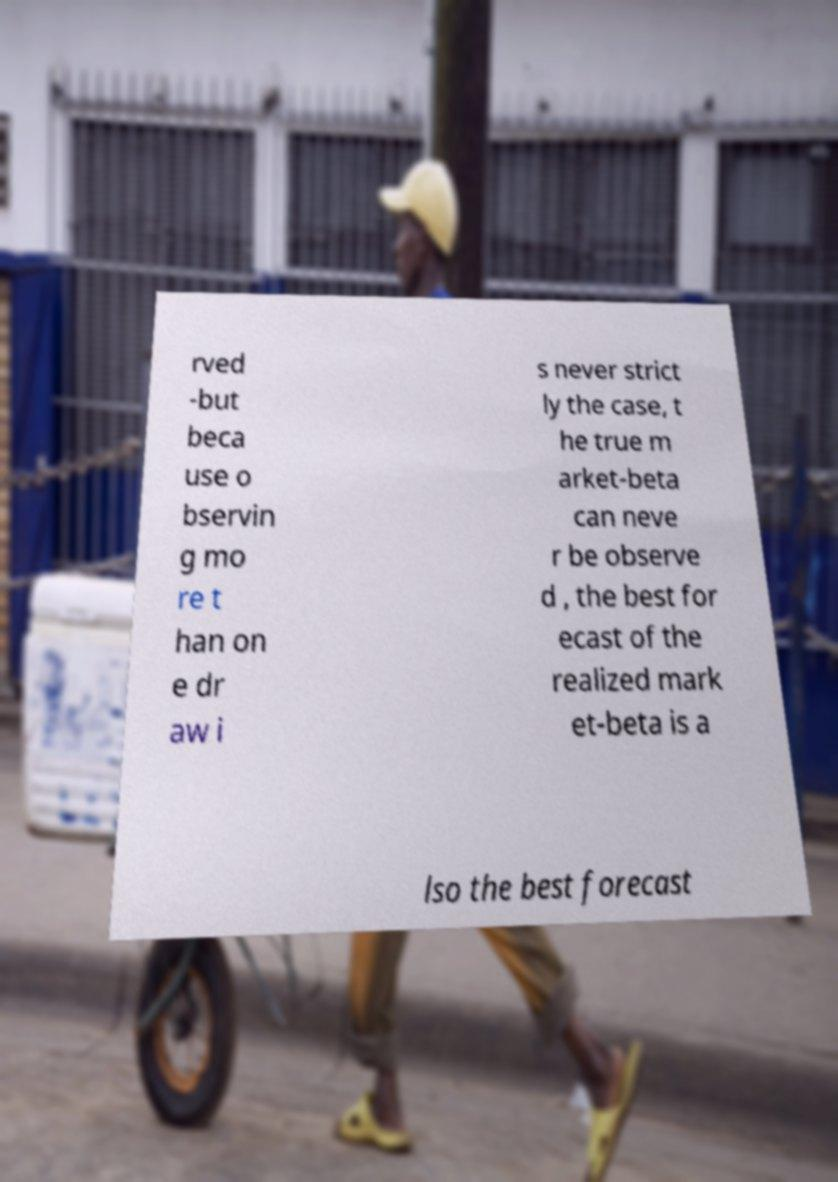Can you accurately transcribe the text from the provided image for me? rved -but beca use o bservin g mo re t han on e dr aw i s never strict ly the case, t he true m arket-beta can neve r be observe d , the best for ecast of the realized mark et-beta is a lso the best forecast 